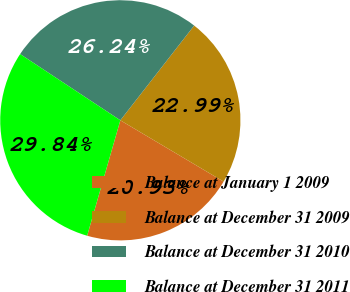<chart> <loc_0><loc_0><loc_500><loc_500><pie_chart><fcel>Balance at January 1 2009<fcel>Balance at December 31 2009<fcel>Balance at December 31 2010<fcel>Balance at December 31 2011<nl><fcel>20.93%<fcel>22.99%<fcel>26.24%<fcel>29.84%<nl></chart> 